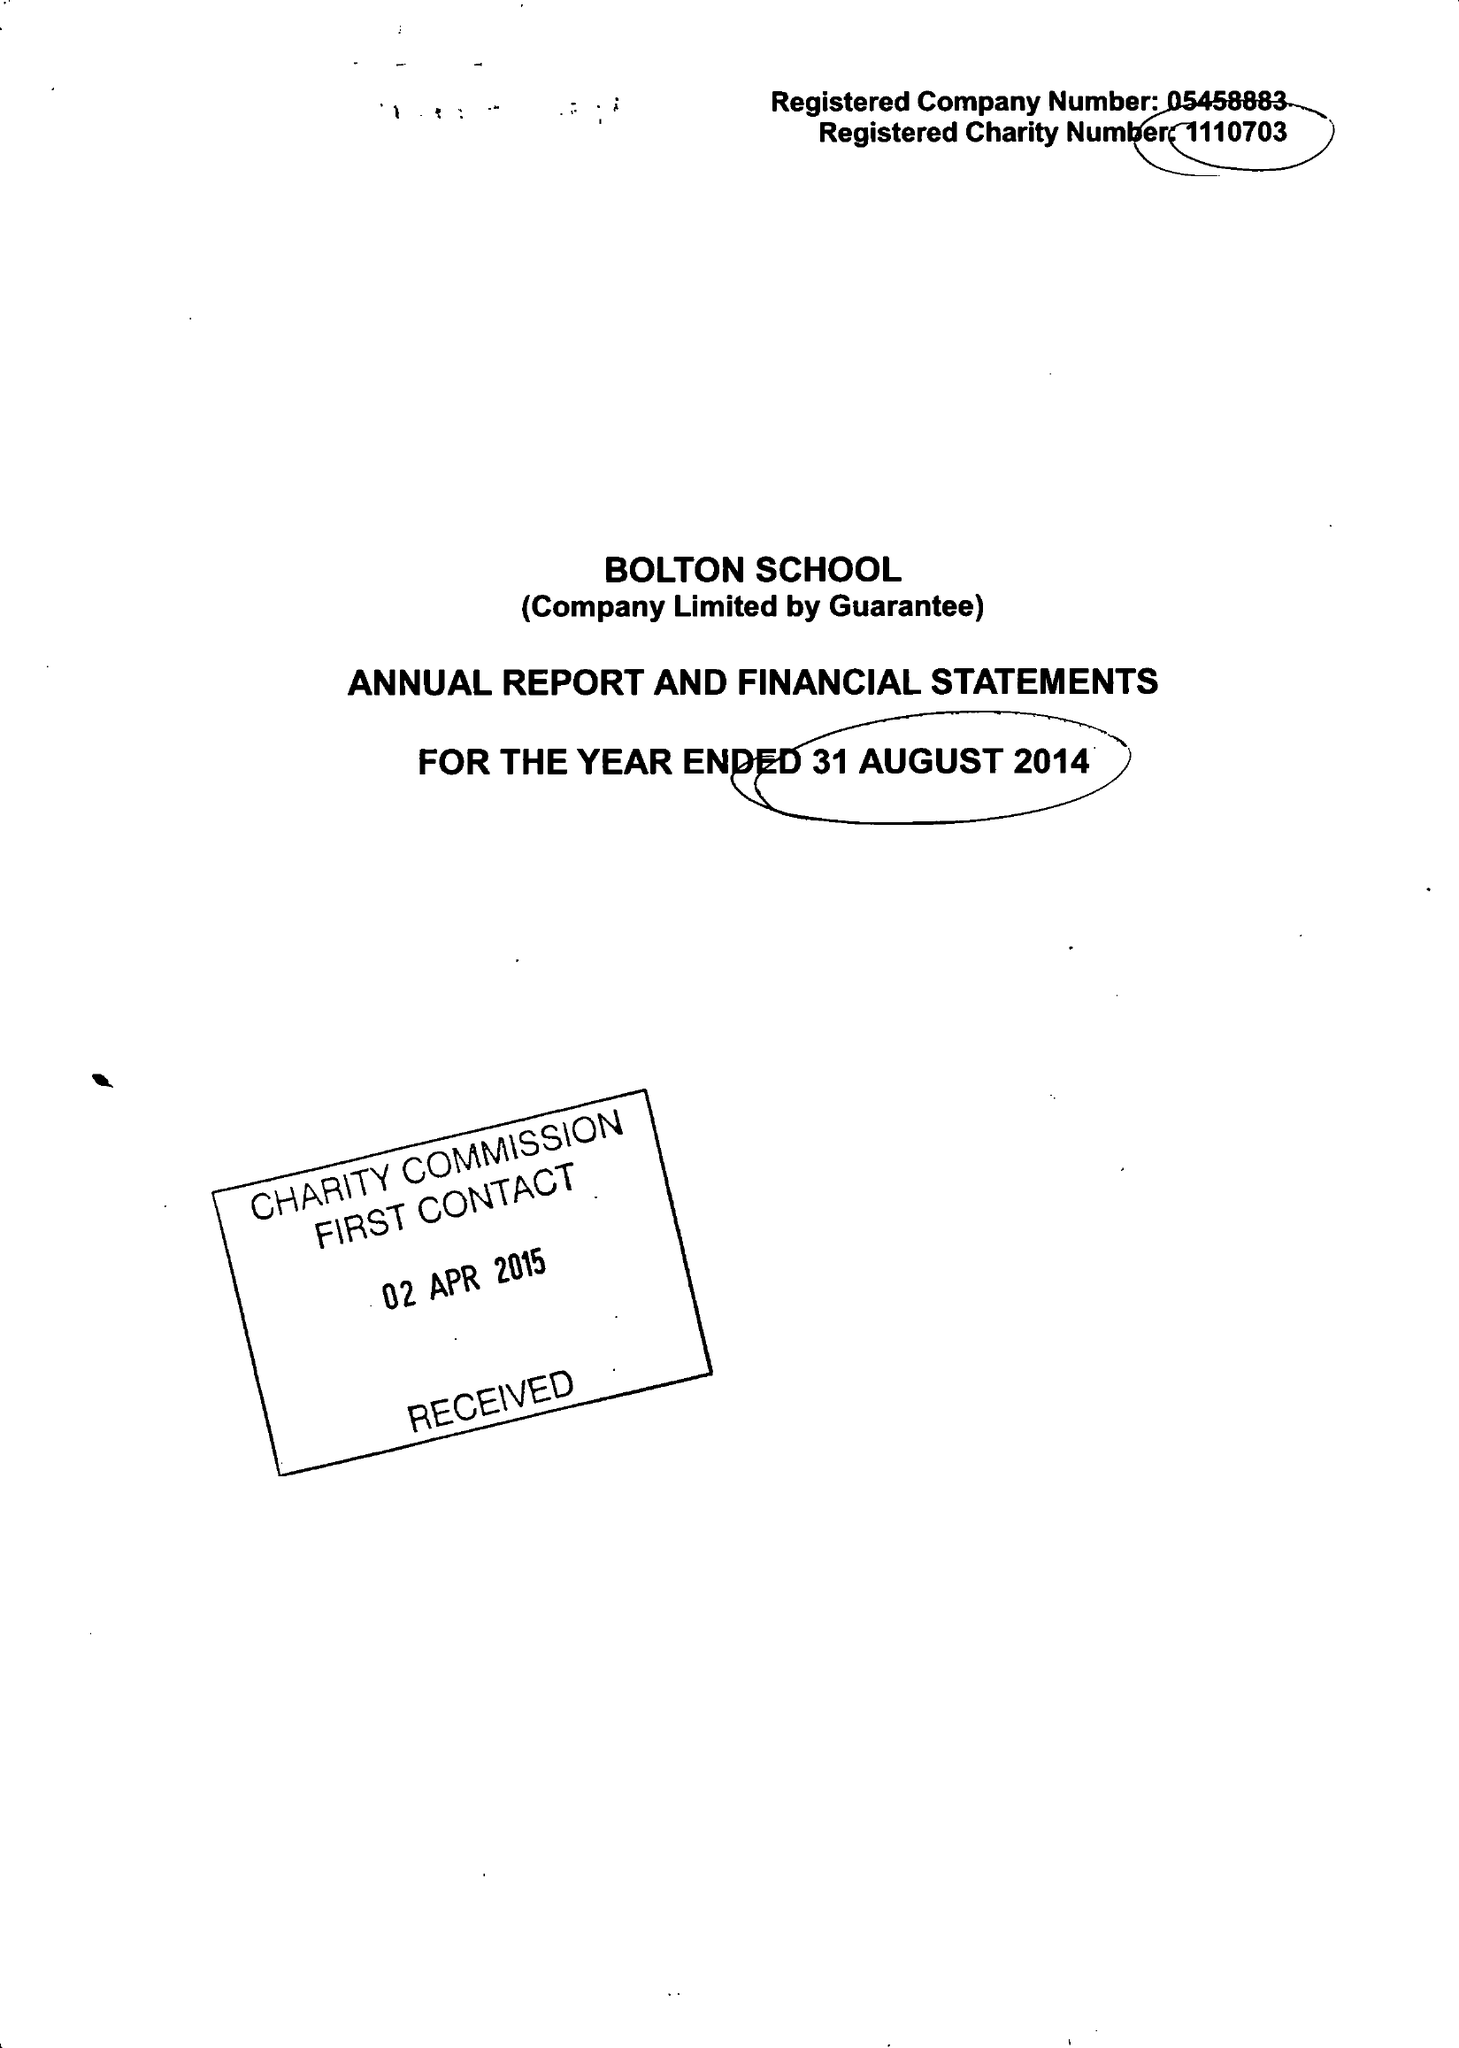What is the value for the report_date?
Answer the question using a single word or phrase. 2014-08-31 